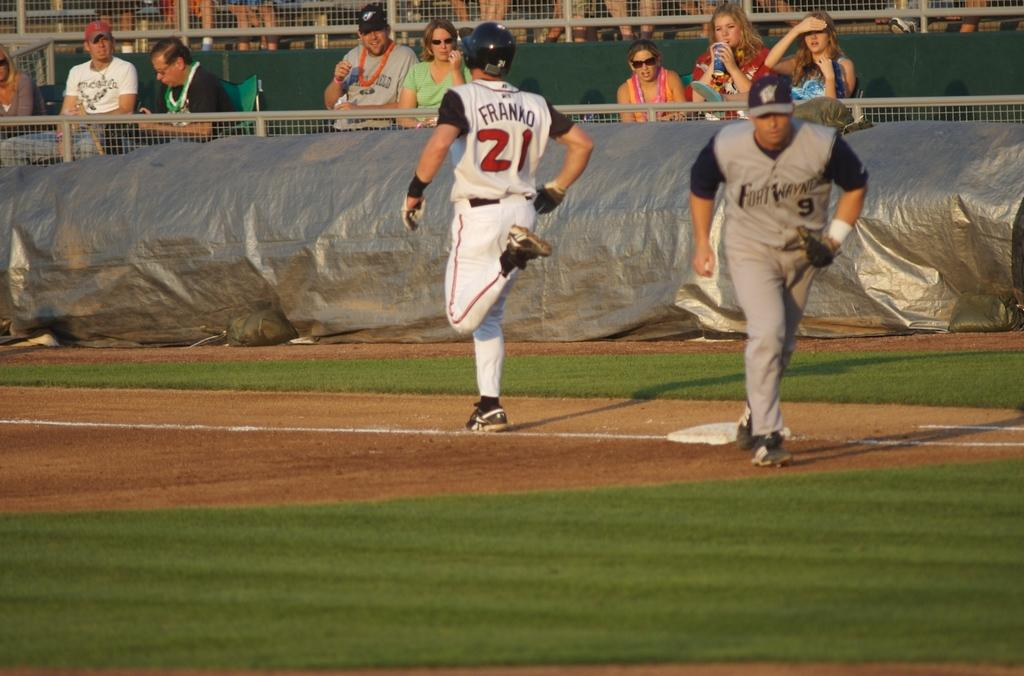<image>
Share a concise interpretation of the image provided. Player number 21, Franko is running past the base. 